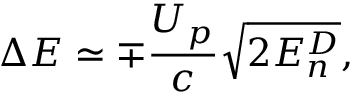Convert formula to latex. <formula><loc_0><loc_0><loc_500><loc_500>\Delta E \simeq \mp \frac { U _ { p } } { c } \sqrt { 2 E _ { n } ^ { D } } ,</formula> 